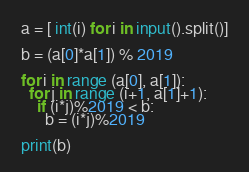<code> <loc_0><loc_0><loc_500><loc_500><_Python_>a = [ int(i) for i in input().split()]

b = (a[0]*a[1]) % 2019

for i in range (a[0], a[1]):
  for j in range (i+1, a[1]+1):
    if (i*j)%2019 < b:
      b = (i*j)%2019
      
print(b)      </code> 